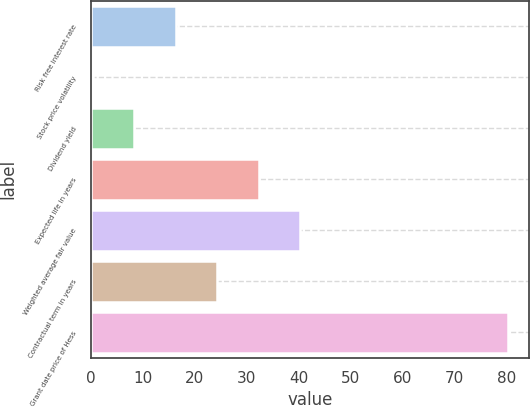<chart> <loc_0><loc_0><loc_500><loc_500><bar_chart><fcel>Risk free interest rate<fcel>Stock price volatility<fcel>Dividend yield<fcel>Expected life in years<fcel>Weighted average fair value<fcel>Contractual term in years<fcel>Grant date price of Hess<nl><fcel>16.36<fcel>0.36<fcel>8.36<fcel>32.36<fcel>40.36<fcel>24.36<fcel>80.35<nl></chart> 